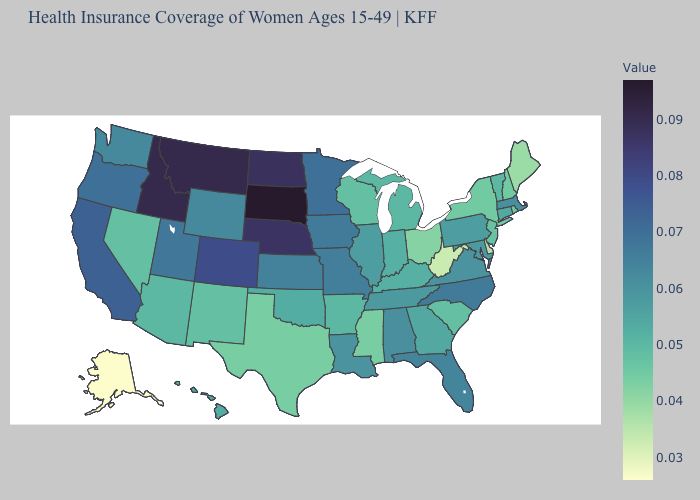Does North Carolina have the highest value in the South?
Quick response, please. Yes. Among the states that border Florida , does Alabama have the lowest value?
Keep it brief. No. Does Alaska have the lowest value in the USA?
Be succinct. Yes. Among the states that border South Dakota , which have the highest value?
Short answer required. Montana. Which states have the lowest value in the USA?
Give a very brief answer. Alaska. Is the legend a continuous bar?
Give a very brief answer. Yes. Among the states that border Alabama , which have the lowest value?
Answer briefly. Mississippi. 